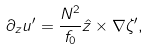<formula> <loc_0><loc_0><loc_500><loc_500>\partial _ { z } u ^ { \prime } = \frac { N ^ { 2 } } { f _ { 0 } } \hat { z } \times \nabla \zeta ^ { \prime } ,</formula> 